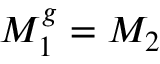<formula> <loc_0><loc_0><loc_500><loc_500>M _ { 1 } ^ { g } = M _ { 2 }</formula> 